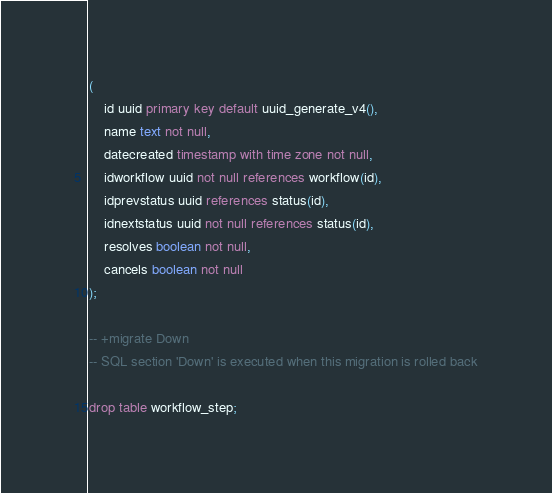Convert code to text. <code><loc_0><loc_0><loc_500><loc_500><_SQL_>(
	id uuid primary key default uuid_generate_v4(),
	name text not null,
	datecreated timestamp with time zone not null,
	idworkflow uuid not null references workflow(id),
	idprevstatus uuid references status(id),
	idnextstatus uuid not null references status(id),
	resolves boolean not null,
	cancels boolean not null
);

-- +migrate Down
-- SQL section 'Down' is executed when this migration is rolled back

drop table workflow_step;</code> 